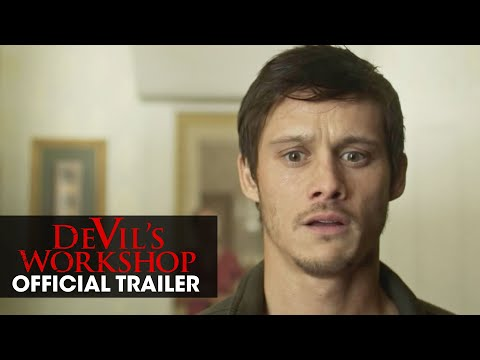Imagine you are a critic reviewing this movie scene. What would your review be? In a seemingly simple yet profoundly effective scene, the actor's expression captures a tension that grips the audience. The use of minimalistic background focuses all attention on the character's emotional state, highlighted by the subtle details in his environment, such as the plain white wall and the single framed painting. The inclusion of the bold red title and trailer indication provides a forewarning of the intense narrative to follow. This teaser promises a thrilling ride filled with suspense and unexpected turns, leaving the viewers eager for more. Provide a shorter review suitable for social media. This movie scene perfectly sets the tone for suspense! The actor's intense expression, minimalistic setting, and bold title make for an intriguing and gripping teaser. Can't wait for the full trailer! #DevilsWorkshop #MovieReview 